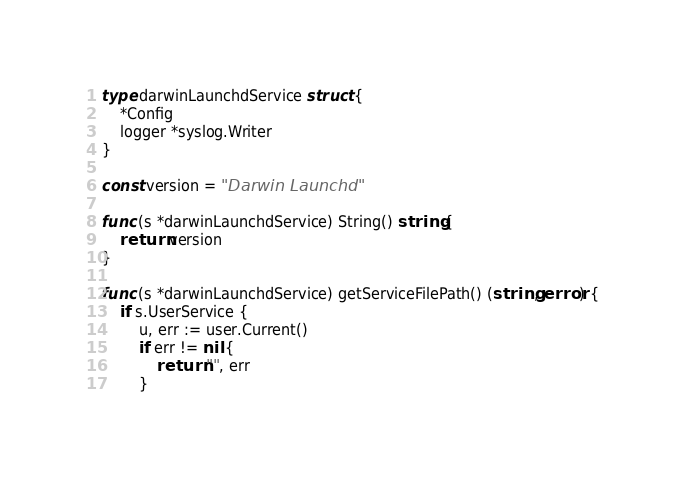<code> <loc_0><loc_0><loc_500><loc_500><_Go_>type darwinLaunchdService struct {
	*Config
	logger *syslog.Writer
}

const version = "Darwin Launchd"

func (s *darwinLaunchdService) String() string {
	return version
}

func (s *darwinLaunchdService) getServiceFilePath() (string, error) {
	if s.UserService {
		u, err := user.Current()
		if err != nil {
			return "", err
		}</code> 